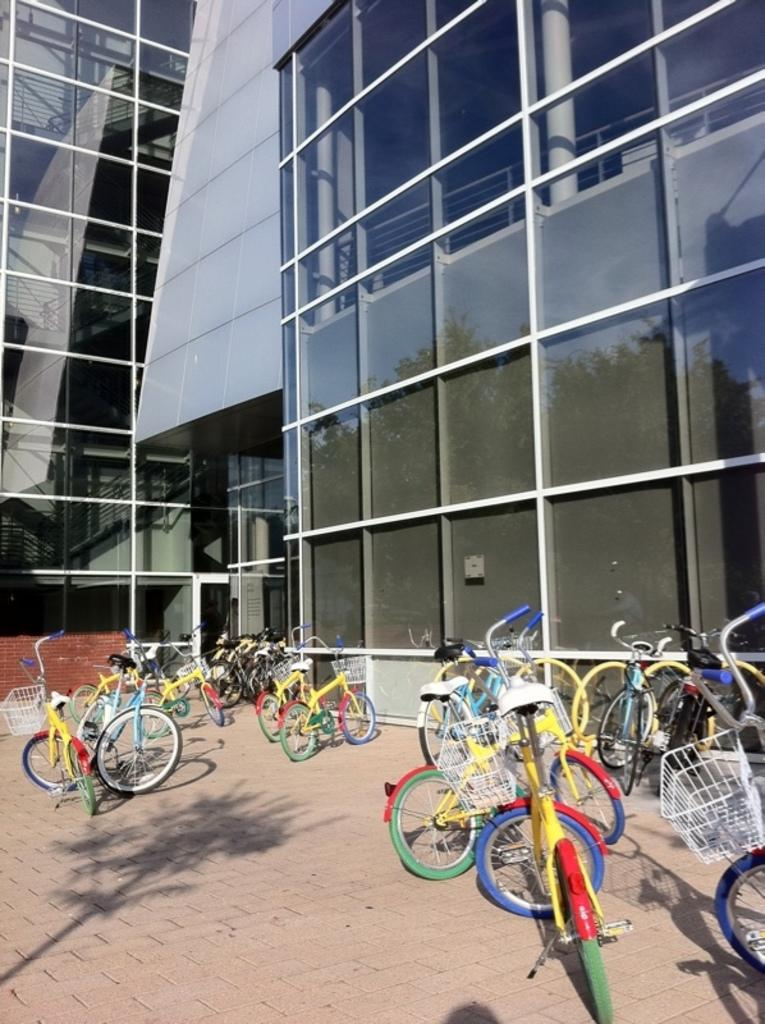What is the main object in the image? There is a bicycle in the image. Where is the bicycle located? The bicycle is on a pavement. What can be seen in the background of the image? There is a building in the background of the image. What type of breakfast is being served in the image? There is no breakfast present in the image; it features a bicycle on a pavement with a building in the background. 